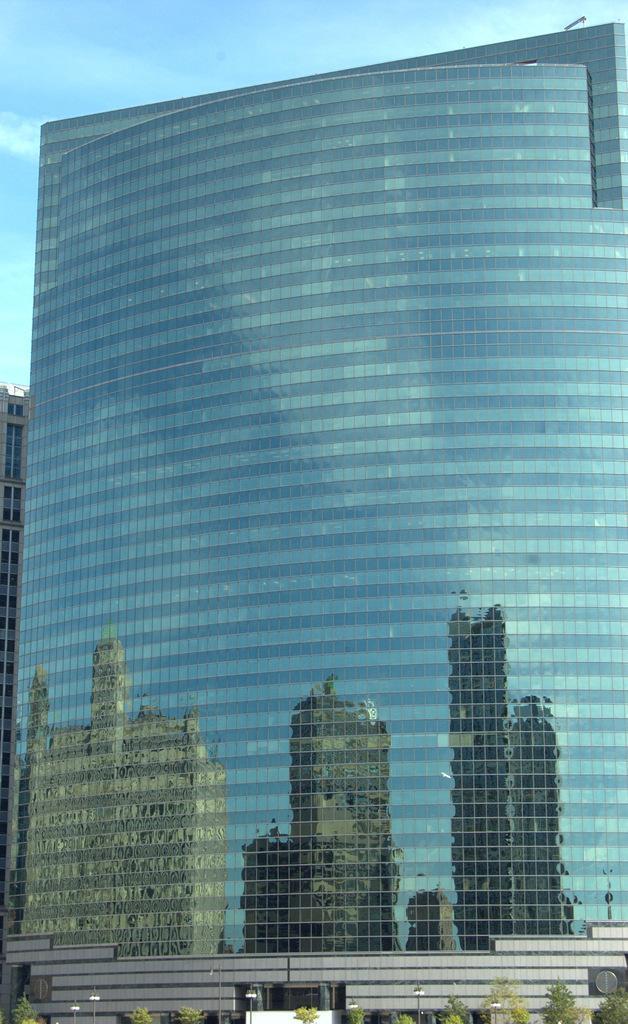Please provide a concise description of this image. In this image there is a skyscraper, trees, poles, lights, and there is reflection of buildings, and in the background there is sky. 